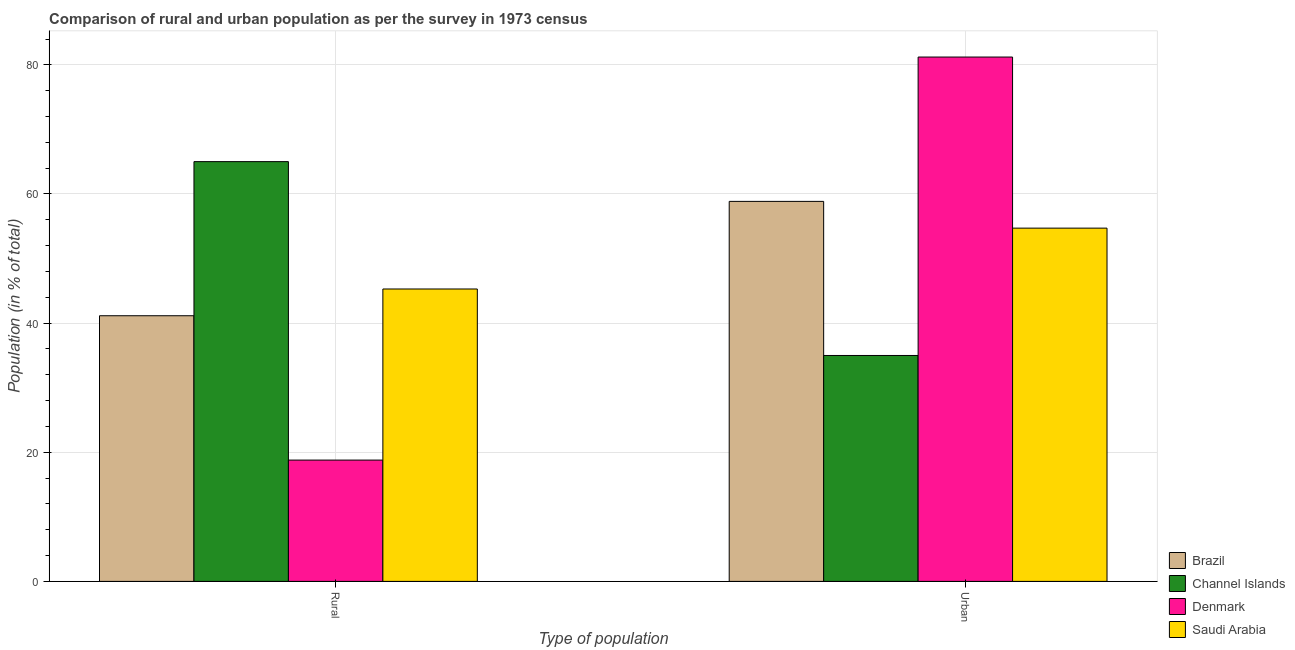Are the number of bars per tick equal to the number of legend labels?
Ensure brevity in your answer.  Yes. What is the label of the 1st group of bars from the left?
Ensure brevity in your answer.  Rural. What is the urban population in Channel Islands?
Provide a short and direct response. 34.99. Across all countries, what is the maximum rural population?
Offer a very short reply. 65.01. Across all countries, what is the minimum rural population?
Make the answer very short. 18.79. In which country was the rural population maximum?
Ensure brevity in your answer.  Channel Islands. What is the total urban population in the graph?
Make the answer very short. 229.77. What is the difference between the urban population in Brazil and that in Saudi Arabia?
Keep it short and to the point. 4.14. What is the difference between the rural population in Channel Islands and the urban population in Denmark?
Ensure brevity in your answer.  -16.2. What is the average urban population per country?
Provide a succinct answer. 57.44. What is the difference between the urban population and rural population in Saudi Arabia?
Your answer should be very brief. 9.42. In how many countries, is the urban population greater than 72 %?
Give a very brief answer. 1. What is the ratio of the urban population in Denmark to that in Brazil?
Ensure brevity in your answer.  1.38. Is the rural population in Denmark less than that in Brazil?
Your response must be concise. Yes. In how many countries, is the rural population greater than the average rural population taken over all countries?
Provide a short and direct response. 2. What does the 2nd bar from the left in Rural represents?
Your response must be concise. Channel Islands. What does the 3rd bar from the right in Rural represents?
Provide a short and direct response. Channel Islands. How many bars are there?
Your answer should be compact. 8. Are all the bars in the graph horizontal?
Ensure brevity in your answer.  No. Are the values on the major ticks of Y-axis written in scientific E-notation?
Keep it short and to the point. No. Where does the legend appear in the graph?
Make the answer very short. Bottom right. How many legend labels are there?
Keep it short and to the point. 4. How are the legend labels stacked?
Offer a very short reply. Vertical. What is the title of the graph?
Ensure brevity in your answer.  Comparison of rural and urban population as per the survey in 1973 census. Does "Mauritius" appear as one of the legend labels in the graph?
Your answer should be compact. No. What is the label or title of the X-axis?
Your response must be concise. Type of population. What is the label or title of the Y-axis?
Keep it short and to the point. Population (in % of total). What is the Population (in % of total) of Brazil in Rural?
Give a very brief answer. 41.15. What is the Population (in % of total) of Channel Islands in Rural?
Provide a short and direct response. 65.01. What is the Population (in % of total) in Denmark in Rural?
Offer a terse response. 18.79. What is the Population (in % of total) in Saudi Arabia in Rural?
Provide a succinct answer. 45.29. What is the Population (in % of total) in Brazil in Urban?
Your answer should be very brief. 58.85. What is the Population (in % of total) in Channel Islands in Urban?
Offer a terse response. 34.99. What is the Population (in % of total) of Denmark in Urban?
Your answer should be very brief. 81.21. What is the Population (in % of total) in Saudi Arabia in Urban?
Make the answer very short. 54.71. Across all Type of population, what is the maximum Population (in % of total) in Brazil?
Offer a terse response. 58.85. Across all Type of population, what is the maximum Population (in % of total) in Channel Islands?
Provide a short and direct response. 65.01. Across all Type of population, what is the maximum Population (in % of total) of Denmark?
Your response must be concise. 81.21. Across all Type of population, what is the maximum Population (in % of total) of Saudi Arabia?
Your response must be concise. 54.71. Across all Type of population, what is the minimum Population (in % of total) in Brazil?
Your response must be concise. 41.15. Across all Type of population, what is the minimum Population (in % of total) of Channel Islands?
Provide a succinct answer. 34.99. Across all Type of population, what is the minimum Population (in % of total) in Denmark?
Provide a succinct answer. 18.79. Across all Type of population, what is the minimum Population (in % of total) of Saudi Arabia?
Offer a very short reply. 45.29. What is the total Population (in % of total) in Saudi Arabia in the graph?
Give a very brief answer. 100. What is the difference between the Population (in % of total) in Brazil in Rural and that in Urban?
Make the answer very short. -17.71. What is the difference between the Population (in % of total) in Channel Islands in Rural and that in Urban?
Offer a very short reply. 30.02. What is the difference between the Population (in % of total) of Denmark in Rural and that in Urban?
Your response must be concise. -62.42. What is the difference between the Population (in % of total) in Saudi Arabia in Rural and that in Urban?
Offer a very short reply. -9.42. What is the difference between the Population (in % of total) of Brazil in Rural and the Population (in % of total) of Channel Islands in Urban?
Keep it short and to the point. 6.16. What is the difference between the Population (in % of total) of Brazil in Rural and the Population (in % of total) of Denmark in Urban?
Give a very brief answer. -40.07. What is the difference between the Population (in % of total) of Brazil in Rural and the Population (in % of total) of Saudi Arabia in Urban?
Provide a short and direct response. -13.57. What is the difference between the Population (in % of total) in Channel Islands in Rural and the Population (in % of total) in Denmark in Urban?
Offer a terse response. -16.2. What is the difference between the Population (in % of total) of Channel Islands in Rural and the Population (in % of total) of Saudi Arabia in Urban?
Offer a terse response. 10.3. What is the difference between the Population (in % of total) of Denmark in Rural and the Population (in % of total) of Saudi Arabia in Urban?
Provide a short and direct response. -35.92. What is the average Population (in % of total) of Denmark per Type of population?
Offer a terse response. 50. What is the difference between the Population (in % of total) of Brazil and Population (in % of total) of Channel Islands in Rural?
Provide a short and direct response. -23.87. What is the difference between the Population (in % of total) in Brazil and Population (in % of total) in Denmark in Rural?
Provide a succinct answer. 22.36. What is the difference between the Population (in % of total) in Brazil and Population (in % of total) in Saudi Arabia in Rural?
Your response must be concise. -4.14. What is the difference between the Population (in % of total) in Channel Islands and Population (in % of total) in Denmark in Rural?
Provide a short and direct response. 46.22. What is the difference between the Population (in % of total) of Channel Islands and Population (in % of total) of Saudi Arabia in Rural?
Your answer should be compact. 19.72. What is the difference between the Population (in % of total) in Denmark and Population (in % of total) in Saudi Arabia in Rural?
Your response must be concise. -26.5. What is the difference between the Population (in % of total) of Brazil and Population (in % of total) of Channel Islands in Urban?
Give a very brief answer. 23.87. What is the difference between the Population (in % of total) in Brazil and Population (in % of total) in Denmark in Urban?
Keep it short and to the point. -22.36. What is the difference between the Population (in % of total) of Brazil and Population (in % of total) of Saudi Arabia in Urban?
Your answer should be very brief. 4.14. What is the difference between the Population (in % of total) in Channel Islands and Population (in % of total) in Denmark in Urban?
Your response must be concise. -46.22. What is the difference between the Population (in % of total) of Channel Islands and Population (in % of total) of Saudi Arabia in Urban?
Give a very brief answer. -19.72. What is the difference between the Population (in % of total) in Denmark and Population (in % of total) in Saudi Arabia in Urban?
Provide a succinct answer. 26.5. What is the ratio of the Population (in % of total) in Brazil in Rural to that in Urban?
Provide a succinct answer. 0.7. What is the ratio of the Population (in % of total) of Channel Islands in Rural to that in Urban?
Ensure brevity in your answer.  1.86. What is the ratio of the Population (in % of total) in Denmark in Rural to that in Urban?
Keep it short and to the point. 0.23. What is the ratio of the Population (in % of total) of Saudi Arabia in Rural to that in Urban?
Provide a succinct answer. 0.83. What is the difference between the highest and the second highest Population (in % of total) of Brazil?
Your response must be concise. 17.71. What is the difference between the highest and the second highest Population (in % of total) of Channel Islands?
Your response must be concise. 30.02. What is the difference between the highest and the second highest Population (in % of total) of Denmark?
Your response must be concise. 62.42. What is the difference between the highest and the second highest Population (in % of total) in Saudi Arabia?
Your response must be concise. 9.42. What is the difference between the highest and the lowest Population (in % of total) of Brazil?
Provide a short and direct response. 17.71. What is the difference between the highest and the lowest Population (in % of total) of Channel Islands?
Your answer should be compact. 30.02. What is the difference between the highest and the lowest Population (in % of total) in Denmark?
Make the answer very short. 62.42. What is the difference between the highest and the lowest Population (in % of total) in Saudi Arabia?
Ensure brevity in your answer.  9.42. 